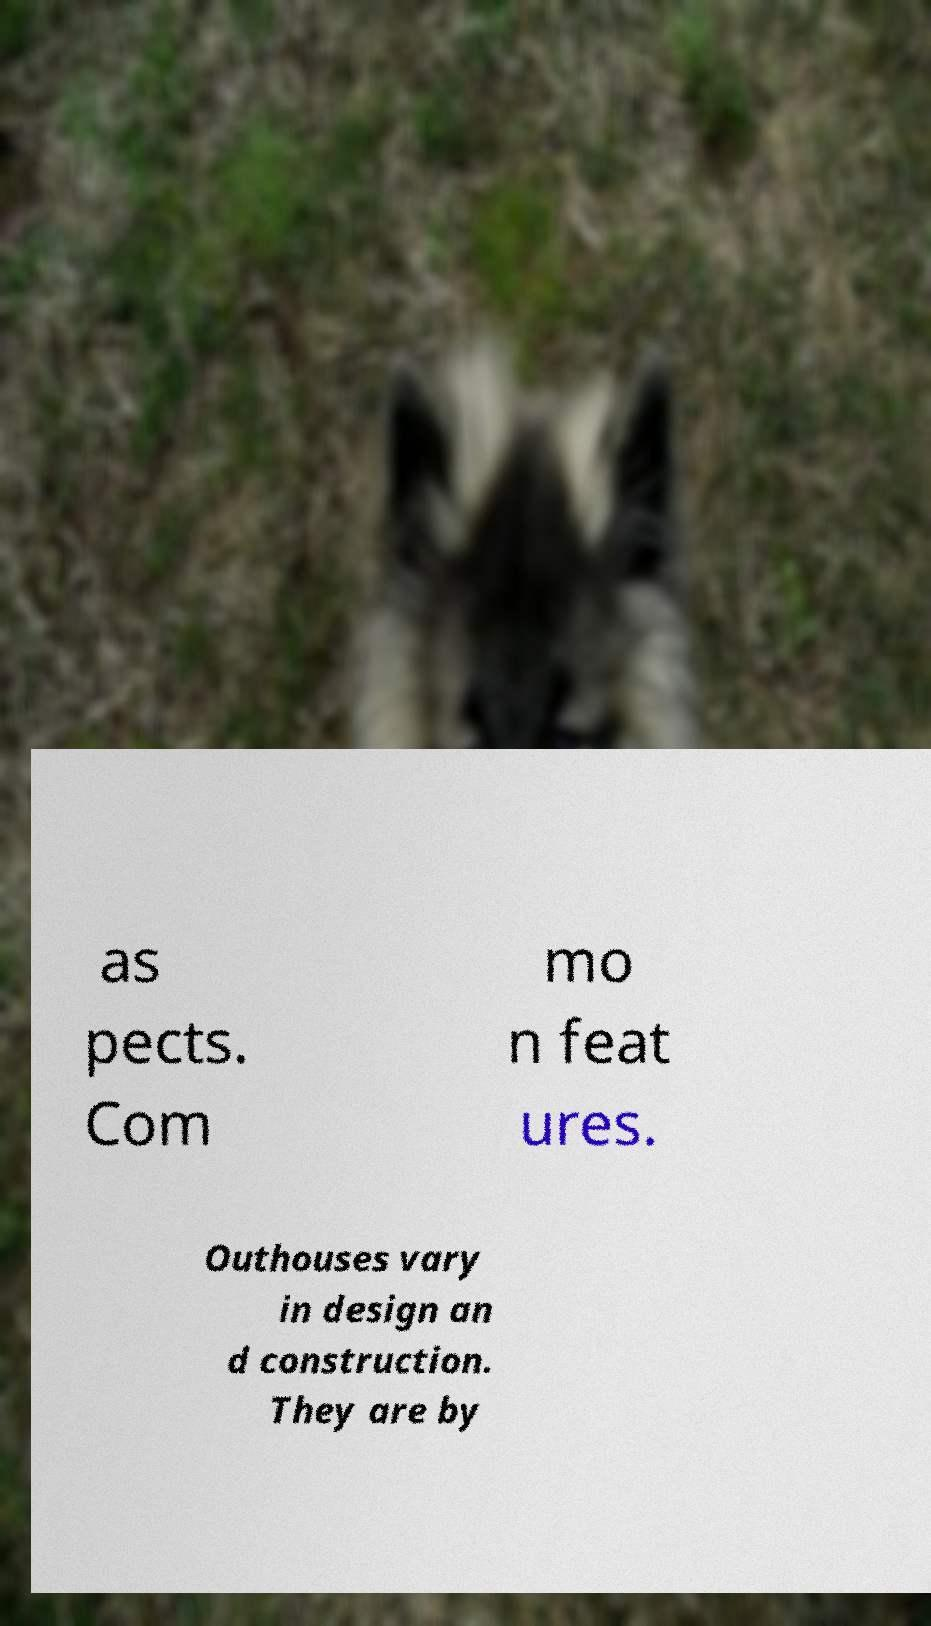Could you assist in decoding the text presented in this image and type it out clearly? as pects. Com mo n feat ures. Outhouses vary in design an d construction. They are by 